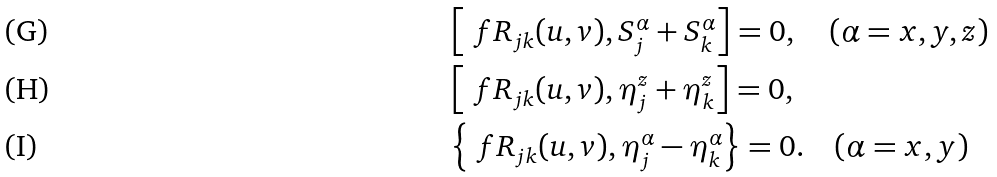Convert formula to latex. <formula><loc_0><loc_0><loc_500><loc_500>& \left [ \ f R _ { j k } ( u , v ) , S _ { j } ^ { \alpha } + S _ { k } ^ { \alpha } \right ] = 0 , \quad ( \alpha = x , y , z ) \\ & \left [ \ f R _ { j k } ( u , v ) , \eta _ { j } ^ { z } + \eta _ { k } ^ { z } \right ] = 0 , \\ & \left \{ \ f R _ { j k } ( u , v ) , \eta _ { j } ^ { \alpha } - \eta _ { k } ^ { \alpha } \right \} = 0 . \quad ( \alpha = x , y )</formula> 